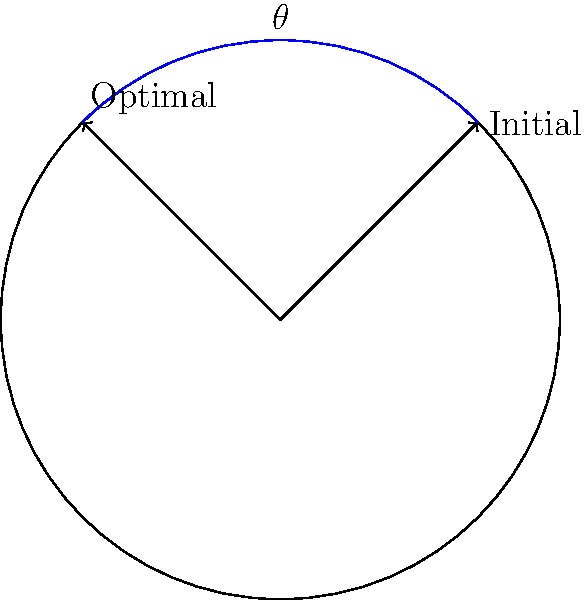A wind turbine is initially aligned at a 45° angle to the north. The wind direction changes, requiring the turbine to rotate to a 135° angle for optimal performance. What is the angle of rotation $\theta$ needed to achieve this optimal alignment? To solve this problem, we need to follow these steps:

1. Identify the initial position: 45°
2. Identify the optimal position: 135°
3. Calculate the angle of rotation:
   
   $\theta = \text{Optimal position} - \text{Initial position}$
   
   $\theta = 135° - 45°$
   
   $\theta = 90°$

The wind turbine needs to rotate 90° clockwise to achieve optimal alignment with the new wind direction.

This rotation ensures that the turbine blades are perpendicular to the wind direction, maximizing energy capture and efficiency.
Answer: 90° 